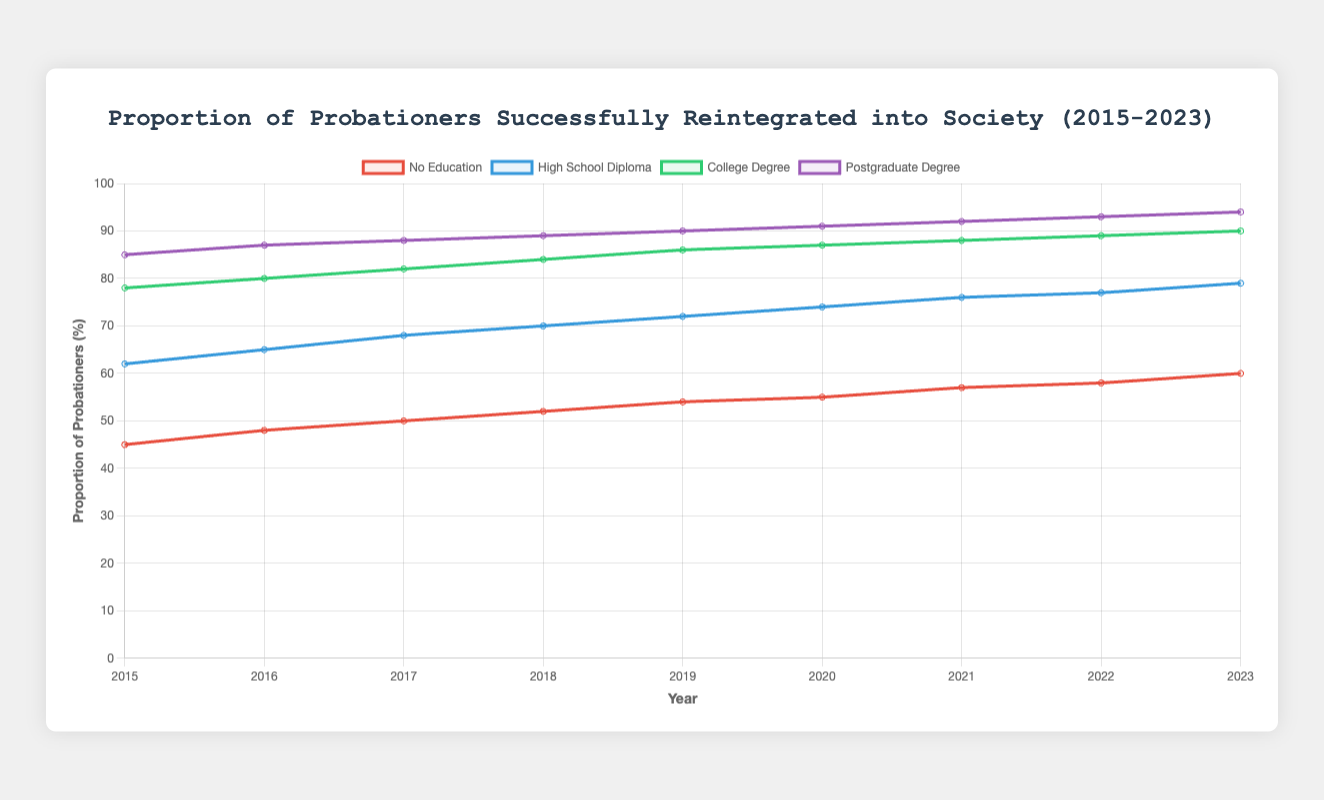what year shows the highest reintegration proportion for postgraduate degree holders? The highest proportion for postgraduate degree holders is seen in the year 2023, where the value reaches 94%.
Answer: 2023 which education level had the largest increase in reintegration proportion from 2015 to 2023? The increase for each education level from 2015 to 2023 is calculated as follows: 
- No Education: 60 - 45 = 15 
- High School Diploma: 79 - 62 = 17 
- College Degree: 90 - 78 = 12 
- Postgraduate Degree: 94 - 85 = 9 
The high school diploma saw the largest increase.
Answer: High School Diploma is there any year where the reintegration proportion of college degree holders is lower than that of high school diploma holders? By inspecting each year's values for both college degree and high school diploma holders over the nine-year period, it is evident that college degree holders always have a higher reintegration proportion than high school diploma holders.
Answer: No What is the average reintegration proportion for probationers with no education over the period 2015-2023? Sum the values for each year for those with no education (45 + 48 + 50 + 52 + 54 + 55 + 57 + 58 + 60) = 429. The average is 429 / 9 = 47.67%.
Answer: 47.67% between college degree holders and high school diploma holders, which group had a more stable reintegration proportion over time? To assess stability, observe the changes year by year. College degree holders' values fluctuate between 78 and 90 (a range of 12), whereas high school diploma holders vary between 62 and 79 (a range of 17). Thus, college degree holders had a more stable reintegration proportion.
Answer: College Degree Holders by how much did the reintegration proportion of probationers with a high school diploma increase from 2018 to 2020? The reintegration proportions in 2018 and 2020 for high school diploma holders are 70% and 74% respectively. The increase is 74 - 70 = 4%.
Answer: 4% which year shows the smallest difference in reintegration proportions between probationers with no education and those with a college degree? Calculate the differences for each year:
- 2015: 78 - 45 = 33
- 2016: 80 - 48 = 32
- 2017: 82 - 50 = 32
- 2018: 84 - 52 = 32
- 2019: 86 - 54 = 32
- 2020: 87 - 55 = 32
- 2021: 88 - 57 = 31
- 2022: 89 - 58 = 31
- 2023: 90 - 60 = 30 The smallest difference is 30 in the year 2023.
Answer: 2023 which line is depicted with a green color? The line representing the proportion of probationers with a college degree is depicted with a green color.
Answer: College Degree 